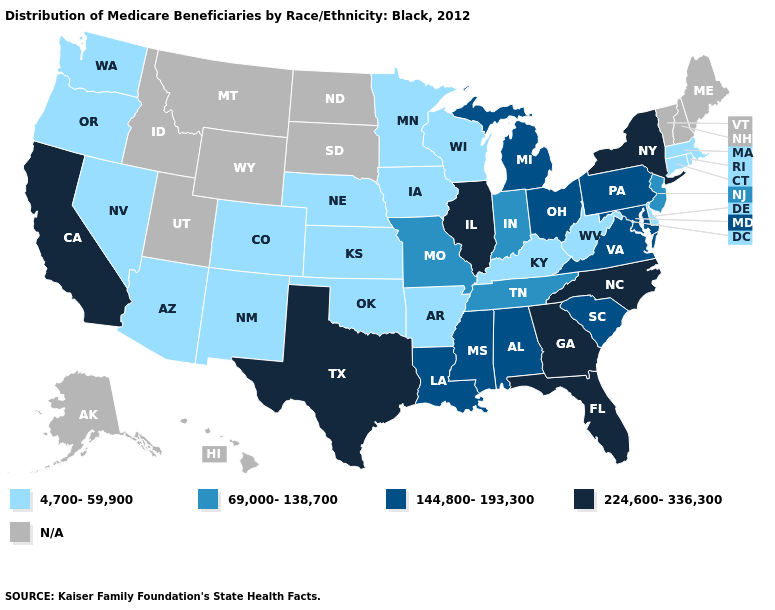Which states have the lowest value in the West?
Give a very brief answer. Arizona, Colorado, Nevada, New Mexico, Oregon, Washington. Which states hav the highest value in the West?
Short answer required. California. Which states have the lowest value in the USA?
Keep it brief. Arizona, Arkansas, Colorado, Connecticut, Delaware, Iowa, Kansas, Kentucky, Massachusetts, Minnesota, Nebraska, Nevada, New Mexico, Oklahoma, Oregon, Rhode Island, Washington, West Virginia, Wisconsin. What is the value of Maine?
Be succinct. N/A. Does the map have missing data?
Concise answer only. Yes. Among the states that border Louisiana , which have the lowest value?
Answer briefly. Arkansas. Which states have the lowest value in the USA?
Be succinct. Arizona, Arkansas, Colorado, Connecticut, Delaware, Iowa, Kansas, Kentucky, Massachusetts, Minnesota, Nebraska, Nevada, New Mexico, Oklahoma, Oregon, Rhode Island, Washington, West Virginia, Wisconsin. Which states have the highest value in the USA?
Answer briefly. California, Florida, Georgia, Illinois, New York, North Carolina, Texas. What is the highest value in the USA?
Give a very brief answer. 224,600-336,300. Name the states that have a value in the range 69,000-138,700?
Be succinct. Indiana, Missouri, New Jersey, Tennessee. What is the value of Arkansas?
Concise answer only. 4,700-59,900. Name the states that have a value in the range 224,600-336,300?
Give a very brief answer. California, Florida, Georgia, Illinois, New York, North Carolina, Texas. Name the states that have a value in the range 144,800-193,300?
Concise answer only. Alabama, Louisiana, Maryland, Michigan, Mississippi, Ohio, Pennsylvania, South Carolina, Virginia. Which states hav the highest value in the West?
Answer briefly. California. Does Oklahoma have the highest value in the South?
Be succinct. No. 